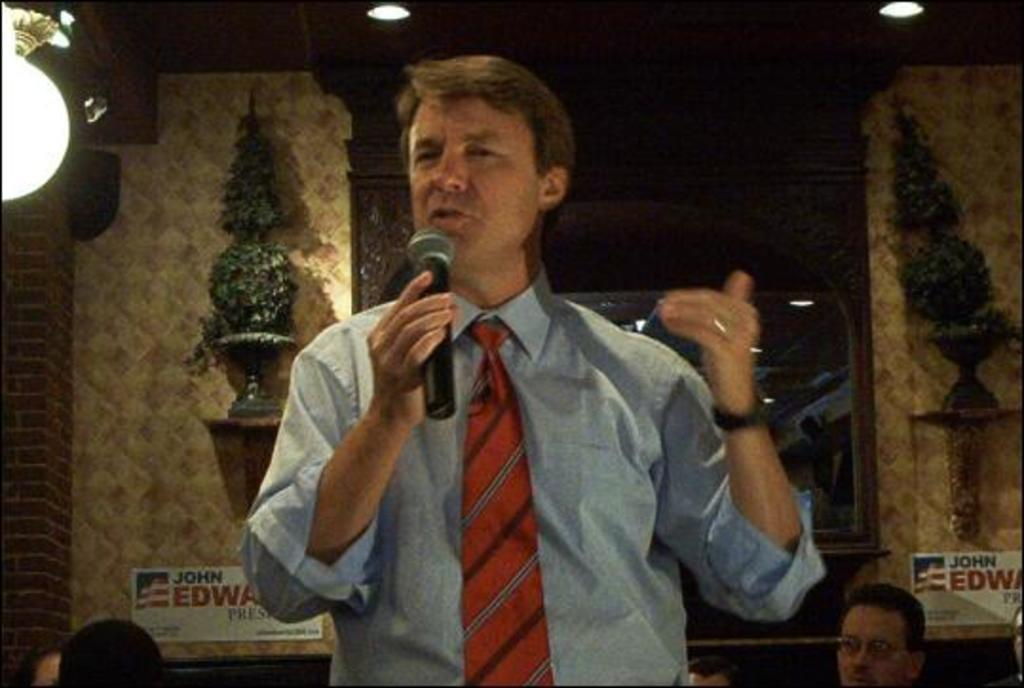What is the person in the image holding? The person is holding a microphone in the image. What is the person doing with the microphone? The person is talking while holding the microphone. What can be seen in the background of the image? There is a wall in the background of the image, and on the wall, there is a stand with decorative items. What type of lighting is present in the image? There are lights on the ceiling in the image. What type of disease is the person talking about in the image? There is no indication of a disease being discussed in the image; the person is simply talking while holding a microphone. 